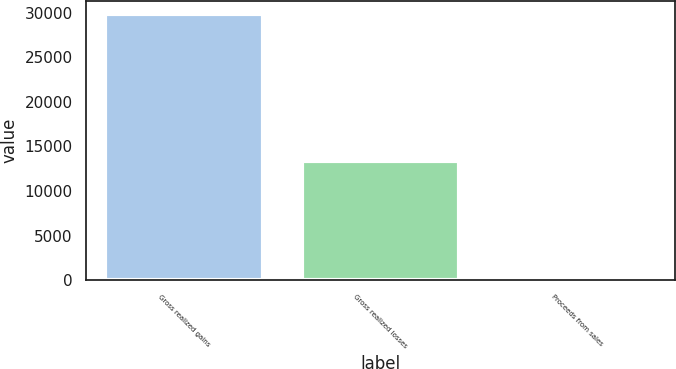Convert chart to OTSL. <chart><loc_0><loc_0><loc_500><loc_500><bar_chart><fcel>Gross realized gains<fcel>Gross realized losses<fcel>Proceeds from sales<nl><fcel>29821<fcel>13361<fcel>1<nl></chart> 